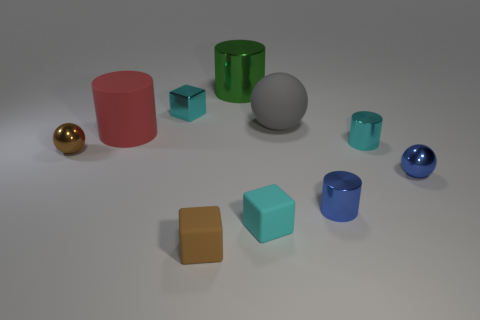Are there any other things that have the same color as the metallic block?
Ensure brevity in your answer.  Yes. What is the shape of the small matte thing that is the same color as the tiny metal cube?
Give a very brief answer. Cube. Does the matte ball have the same size as the block that is behind the brown metal object?
Your answer should be very brief. No. What is the shape of the small matte thing right of the big green thing?
Make the answer very short. Cube. Are there any other things that are the same shape as the large gray rubber object?
Offer a terse response. Yes. Is there a tiny object?
Keep it short and to the point. Yes. There is a rubber cube that is behind the brown matte cube; is its size the same as the metallic thing that is in front of the small blue ball?
Provide a succinct answer. Yes. What is the sphere that is both in front of the tiny cyan shiny cylinder and on the right side of the large green metal cylinder made of?
Offer a very short reply. Metal. How many cylinders are to the right of the small blue cylinder?
Your answer should be very brief. 1. The other tiny sphere that is made of the same material as the blue ball is what color?
Your answer should be compact. Brown. 